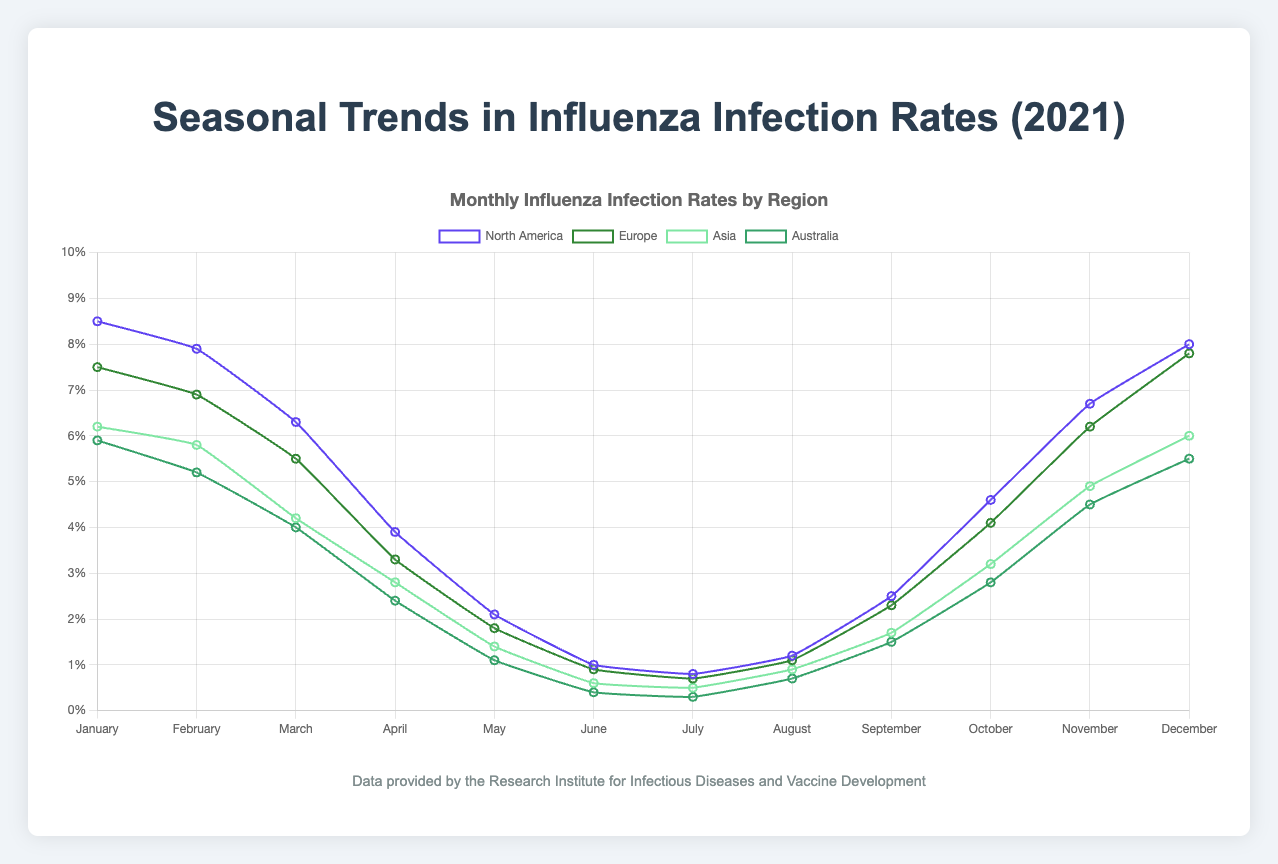Which region had the highest infection rate in January? Observe the figure and locate the data point for January for each region. The highest value among them is the answer. North America had the highest infection rate at 8.5%.
Answer: North America What is the average infection rate in Asia for the first quarter (January to March)? Look at the infection rates in Asia for January (6.2%), February (5.8%), and March (4.2%). Sum these values and divide by 3 to get the average: (6.2 + 5.8 + 4.2) / 3 = 5.4%.
Answer: 5.4% Compare the infection rates in July for all regions. Which region has the lowest rate? Examine the figure and find the data points for July for each region. The region with the smallest value is the answer. In July, the infection rates are North America: 0.8%, Europe: 0.7%, Asia: 0.5%, and Australia: 0.3%. Australia has the lowest rate.
Answer: Australia How did the infection rate change in North America from September to October? Identify the infection rates in North America for September (2.5%) and October (4.6%). Calculate the difference: 4.6% - 2.5% = 2.1%. The rate increased by 2.1%.
Answer: Increased by 2.1% What is the total annual infection rate for Europe? Add up the monthly infection rates in Europe: 7.5 + 6.9 + 5.5 + 3.3 + 1.8 + 0.9 + 0.7 + 1.1 + 2.3 + 4.1 + 6.2 + 7.8 = 48.1%. The total rate is 48.1%.
Answer: 48.1% Compare the infection rates in February between North America and Europe. Which has a higher rate? Look at the infection rates in February for North America (7.9%) and Europe (6.9%). North America has the higher rate as 7.9% > 6.9%.
Answer: North America What is the difference between the highest and lowest infection rates in Australia throughout the year? Find the highest (5.9% in January) and lowest (0.3% in July) infection rates in Australia. Subtract the lowest from the highest: 5.9% - 0.3% = 5.6%. The difference is 5.6%.
Answer: 5.6% Which region shows the most significant seasonal variation in infection rates? Analyze the graph for the amplitude of fluctuations in infection rates. North America shows the highest seasonal variation with the rate ranging from 8.5% to 0.8%.
Answer: North America What is the quarterly average infection rate for North America in the last quarter (October to December)? Identify the infection rates for October (4.6%), November (6.7%), and December (8.0%). Calculate the average: (4.6 + 6.7 + 8.0) / 3 = 6.43%. The average is 6.43%.
Answer: 6.43% In which month did all regions have the lowest infection rates? Examine the figure to identify the month with the lowest infection rates across all regions. This occurs in July: North America (0.8%), Europe (0.7%), Asia (0.5%), and Australia (0.3%).
Answer: July 